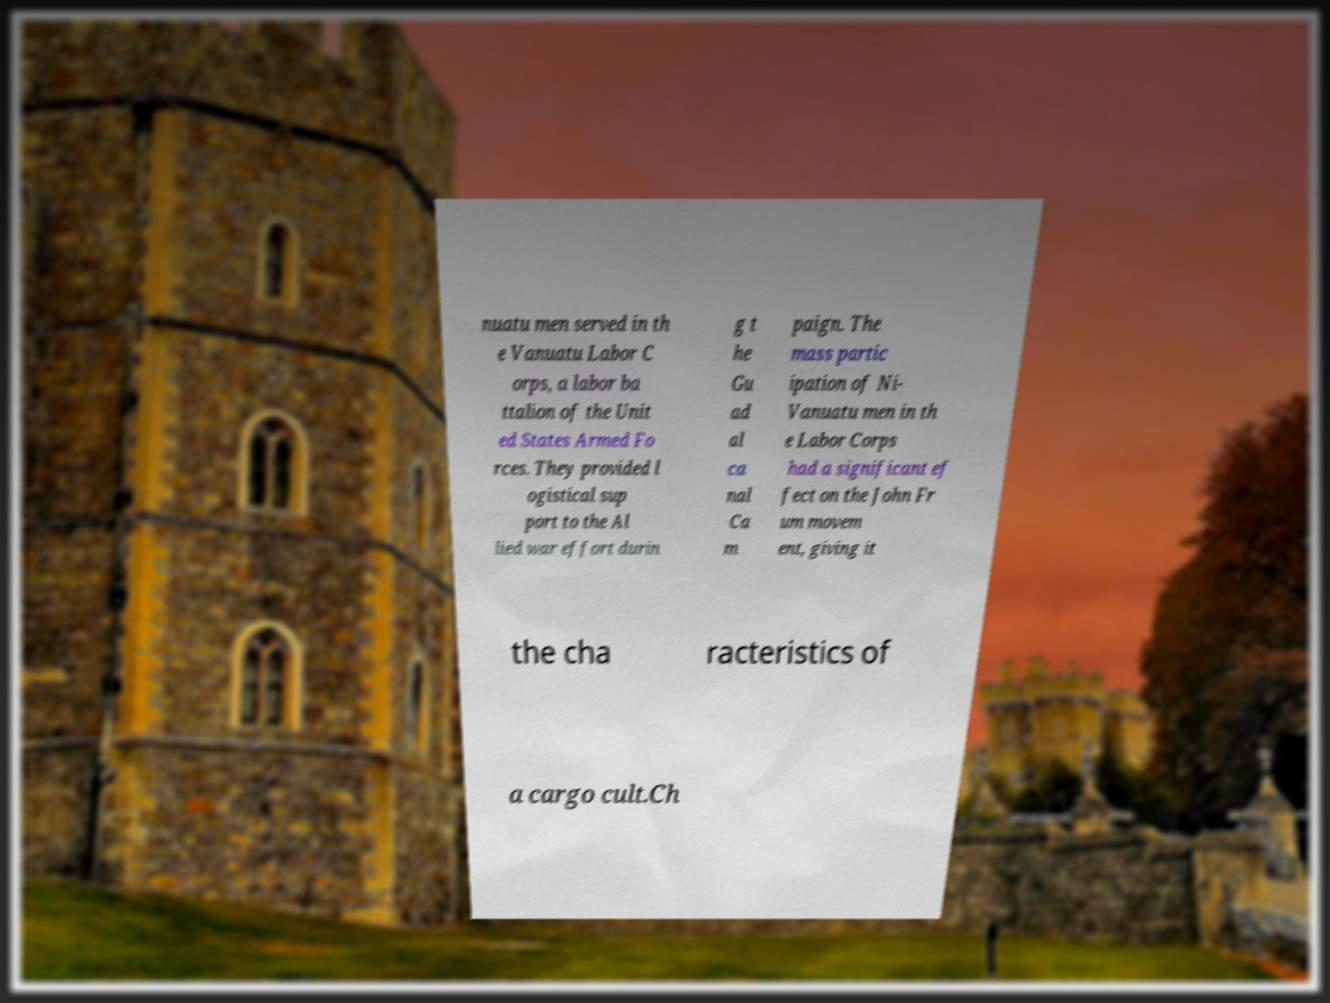I need the written content from this picture converted into text. Can you do that? nuatu men served in th e Vanuatu Labor C orps, a labor ba ttalion of the Unit ed States Armed Fo rces. They provided l ogistical sup port to the Al lied war effort durin g t he Gu ad al ca nal Ca m paign. The mass partic ipation of Ni- Vanuatu men in th e Labor Corps had a significant ef fect on the John Fr um movem ent, giving it the cha racteristics of a cargo cult.Ch 